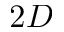Convert formula to latex. <formula><loc_0><loc_0><loc_500><loc_500>2 D</formula> 